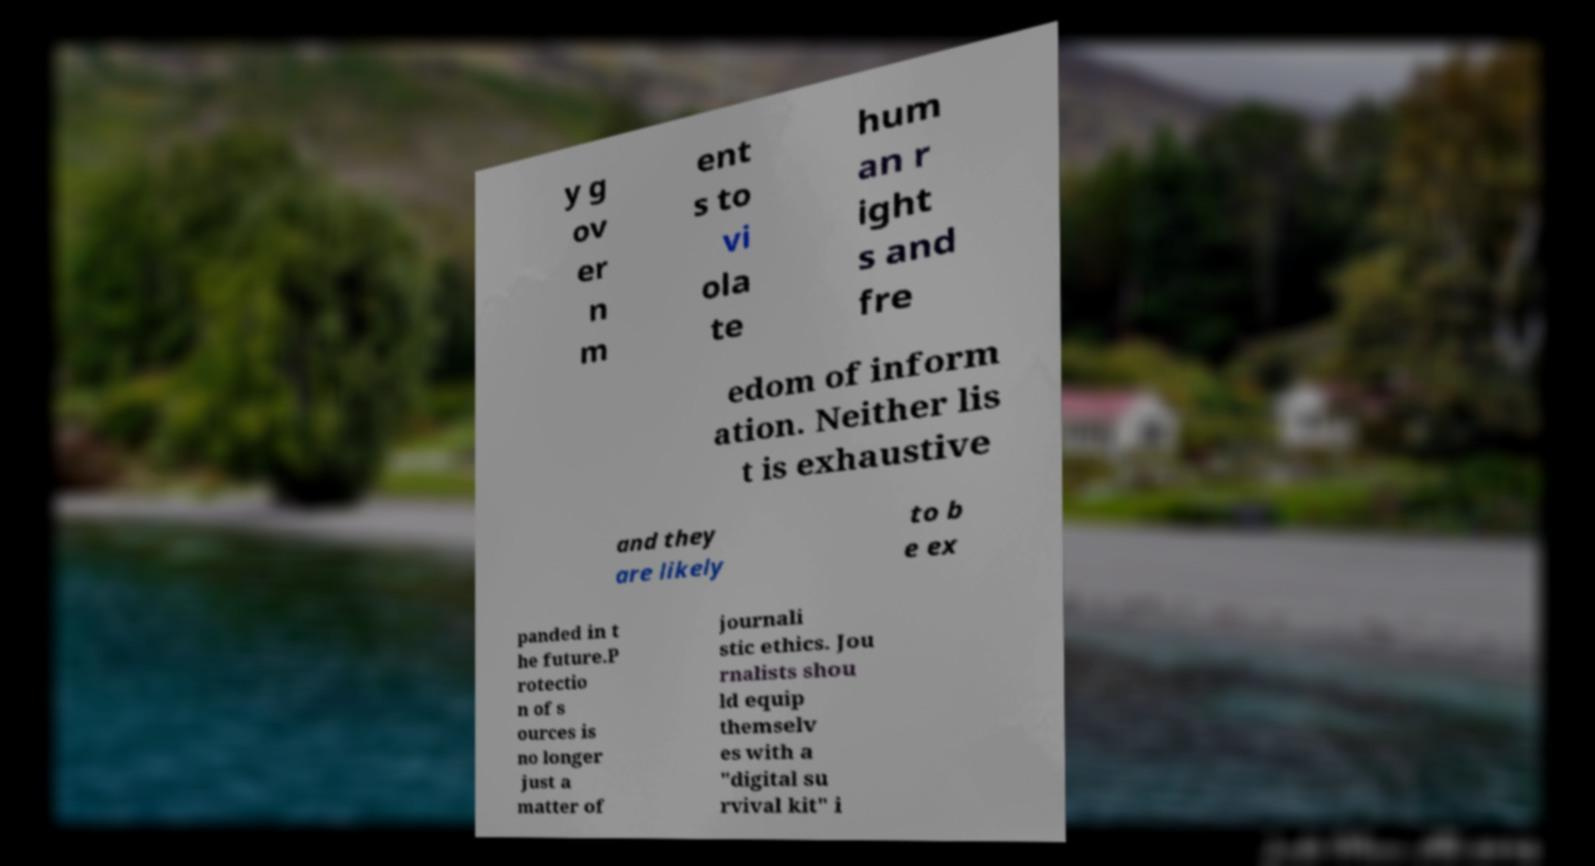Could you assist in decoding the text presented in this image and type it out clearly? y g ov er n m ent s to vi ola te hum an r ight s and fre edom of inform ation. Neither lis t is exhaustive and they are likely to b e ex panded in t he future.P rotectio n of s ources is no longer just a matter of journali stic ethics. Jou rnalists shou ld equip themselv es with a "digital su rvival kit" i 